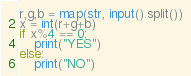<code> <loc_0><loc_0><loc_500><loc_500><_Python_>r,g,b = map(str, input().split())
x = int(r+g+b)
if x%4 == 0:
    print("YES")
else:
    print("NO")</code> 